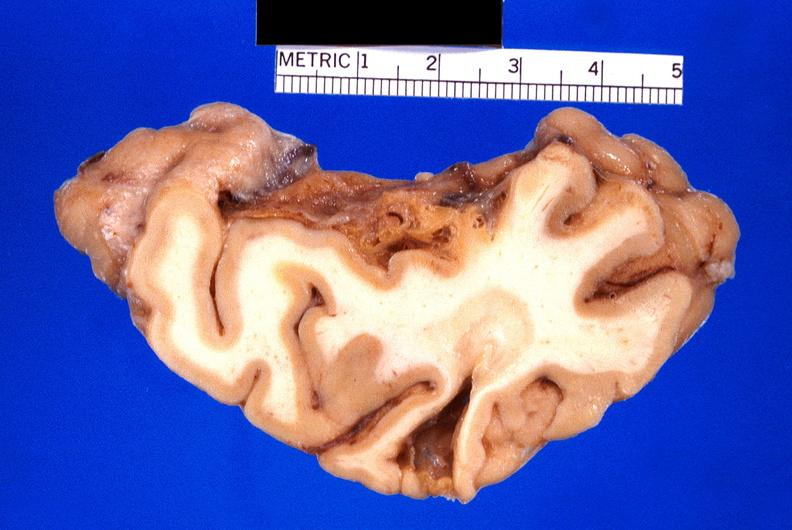what does this image show?
Answer the question using a single word or phrase. Brain 